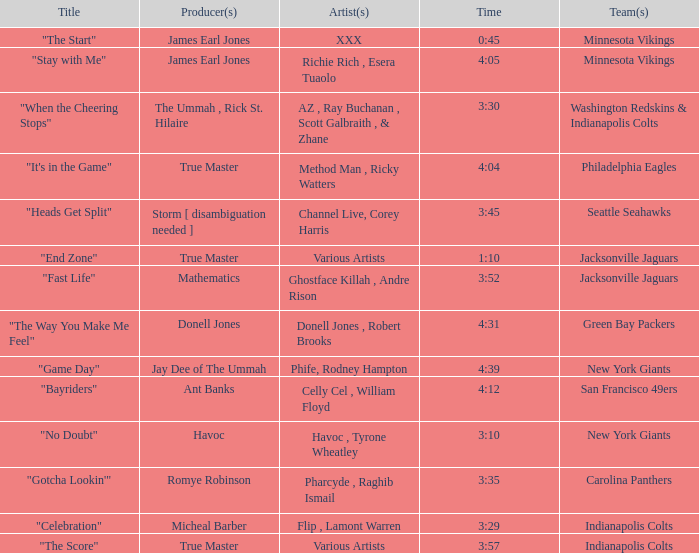Who produced "Fast Life"? Mathematics. 